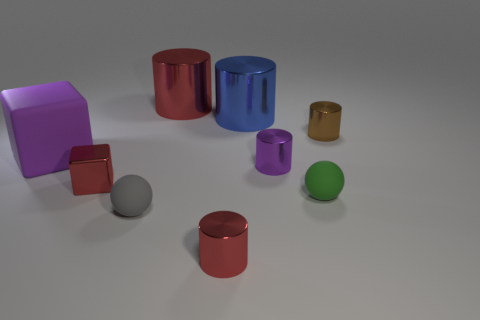Is there a green ball made of the same material as the tiny gray sphere?
Provide a short and direct response. Yes. Is there anything else that has the same material as the brown thing?
Make the answer very short. Yes. What color is the rubber block?
Your answer should be compact. Purple. What color is the ball that is the same size as the green object?
Ensure brevity in your answer.  Gray. What number of shiny things are either small green spheres or small cyan cylinders?
Make the answer very short. 0. What number of things are left of the tiny brown thing and to the right of the large red shiny thing?
Make the answer very short. 4. What number of other objects are the same size as the red metal cube?
Offer a very short reply. 5. Is the size of the red cylinder that is behind the small brown object the same as the metal thing in front of the tiny gray rubber sphere?
Provide a succinct answer. No. How many objects are cyan matte cubes or red objects that are in front of the small gray object?
Your answer should be compact. 1. There is a matte ball to the left of the tiny purple thing; how big is it?
Provide a succinct answer. Small. 